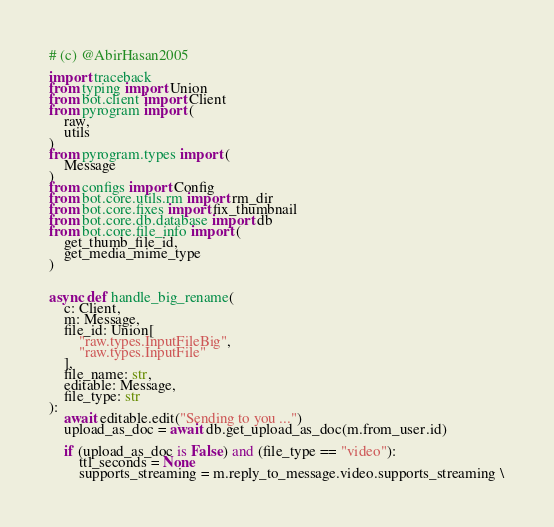Convert code to text. <code><loc_0><loc_0><loc_500><loc_500><_Python_># (c) @AbirHasan2005

import traceback
from typing import Union
from bot.client import Client
from pyrogram import (
    raw,
    utils
)
from pyrogram.types import (
    Message
)
from configs import Config
from bot.core.utils.rm import rm_dir
from bot.core.fixes import fix_thumbnail
from bot.core.db.database import db
from bot.core.file_info import (
    get_thumb_file_id,
    get_media_mime_type
)


async def handle_big_rename(
    c: Client,
    m: Message,
    file_id: Union[
        "raw.types.InputFileBig",
        "raw.types.InputFile"
    ],
    file_name: str,
    editable: Message,
    file_type: str
):
    await editable.edit("Sending to you ...")
    upload_as_doc = await db.get_upload_as_doc(m.from_user.id)

    if (upload_as_doc is False) and (file_type == "video"):
        ttl_seconds = None
        supports_streaming = m.reply_to_message.video.supports_streaming \</code> 